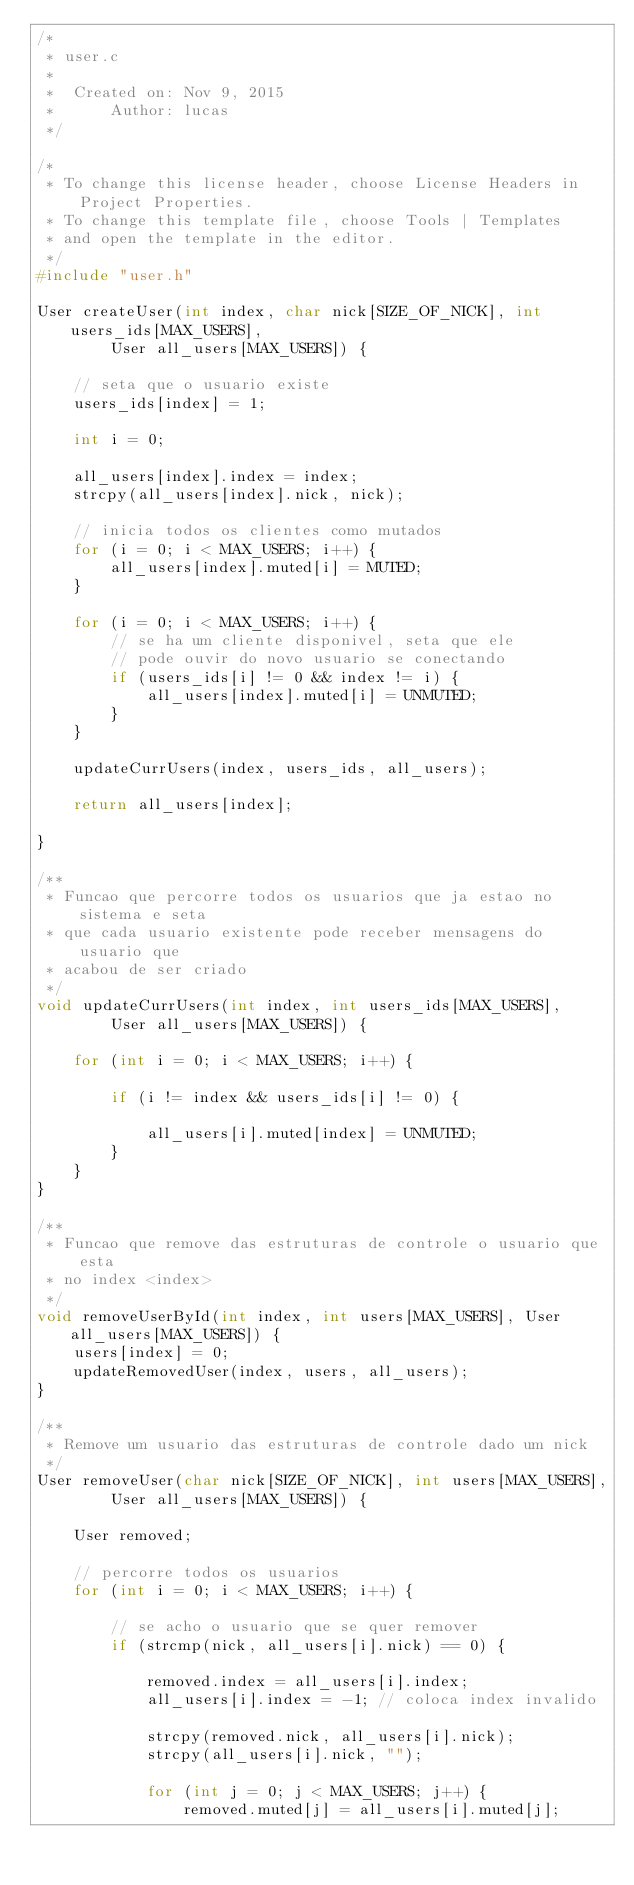<code> <loc_0><loc_0><loc_500><loc_500><_C_>/*
 * user.c
 *
 *  Created on: Nov 9, 2015
 *      Author: lucas
 */

/*
 * To change this license header, choose License Headers in Project Properties.
 * To change this template file, choose Tools | Templates
 * and open the template in the editor.
 */
#include "user.h"

User createUser(int index, char nick[SIZE_OF_NICK], int users_ids[MAX_USERS],
		User all_users[MAX_USERS]) {

	// seta que o usuario existe
	users_ids[index] = 1;

	int i = 0;

	all_users[index].index = index;
	strcpy(all_users[index].nick, nick);

	// inicia todos os clientes como mutados
	for (i = 0; i < MAX_USERS; i++) {
		all_users[index].muted[i] = MUTED;
	}

	for (i = 0; i < MAX_USERS; i++) {
		// se ha um cliente disponivel, seta que ele
		// pode ouvir do novo usuario se conectando
		if (users_ids[i] != 0 && index != i) {
			all_users[index].muted[i] = UNMUTED;
		}
	}

	updateCurrUsers(index, users_ids, all_users);

	return all_users[index];

}

/**
 * Funcao que percorre todos os usuarios que ja estao no sistema e seta
 * que cada usuario existente pode receber mensagens do usuario que
 * acabou de ser criado
 */
void updateCurrUsers(int index, int users_ids[MAX_USERS],
		User all_users[MAX_USERS]) {

	for (int i = 0; i < MAX_USERS; i++) {

		if (i != index && users_ids[i] != 0) {

			all_users[i].muted[index] = UNMUTED;
		}
	}
}

/**
 * Funcao que remove das estruturas de controle o usuario que esta
 * no index <index>
 */
void removeUserById(int index, int users[MAX_USERS], User all_users[MAX_USERS]) {
	users[index] = 0;
	updateRemovedUser(index, users, all_users);
}

/**
 * Remove um usuario das estruturas de controle dado um nick
 */
User removeUser(char nick[SIZE_OF_NICK], int users[MAX_USERS],
		User all_users[MAX_USERS]) {

	User removed;

	// percorre todos os usuarios
	for (int i = 0; i < MAX_USERS; i++) {

		// se acho o usuario que se quer remover
		if (strcmp(nick, all_users[i].nick) == 0) {

			removed.index = all_users[i].index;
			all_users[i].index = -1; // coloca index invalido

			strcpy(removed.nick, all_users[i].nick);
			strcpy(all_users[i].nick, "");

			for (int j = 0; j < MAX_USERS; j++) {
				removed.muted[j] = all_users[i].muted[j];</code> 